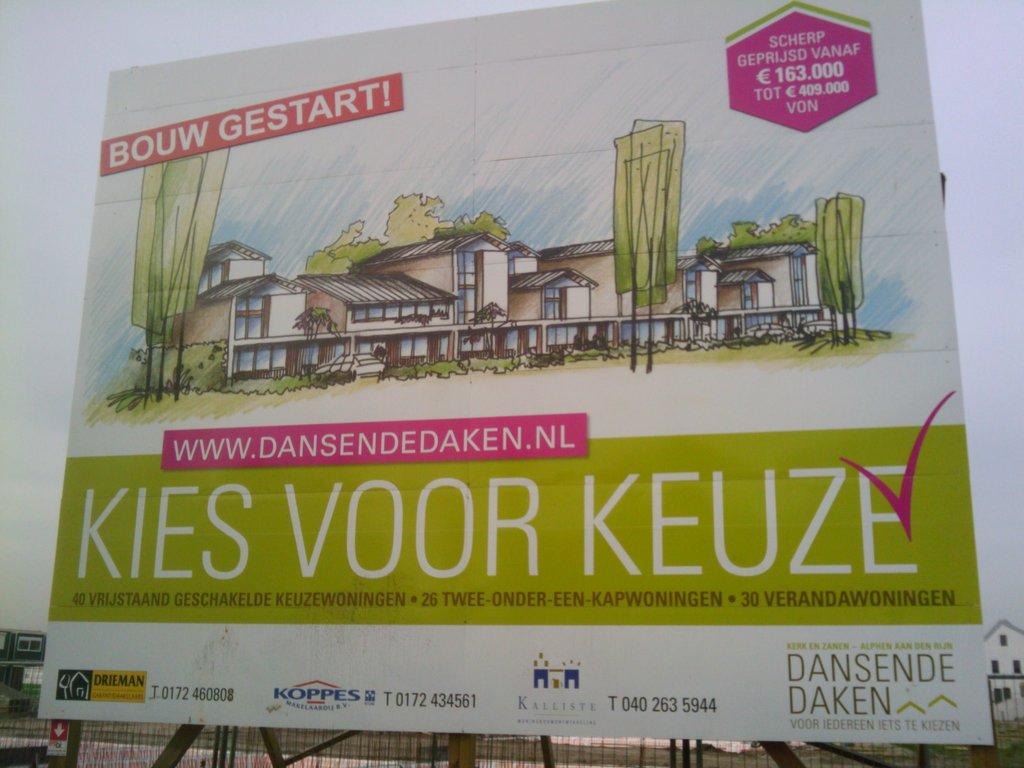What is the website shown?
Ensure brevity in your answer.  Www.dansendedaken.nl. Which company produced this advertisement board?
Make the answer very short. Dansende daken. 